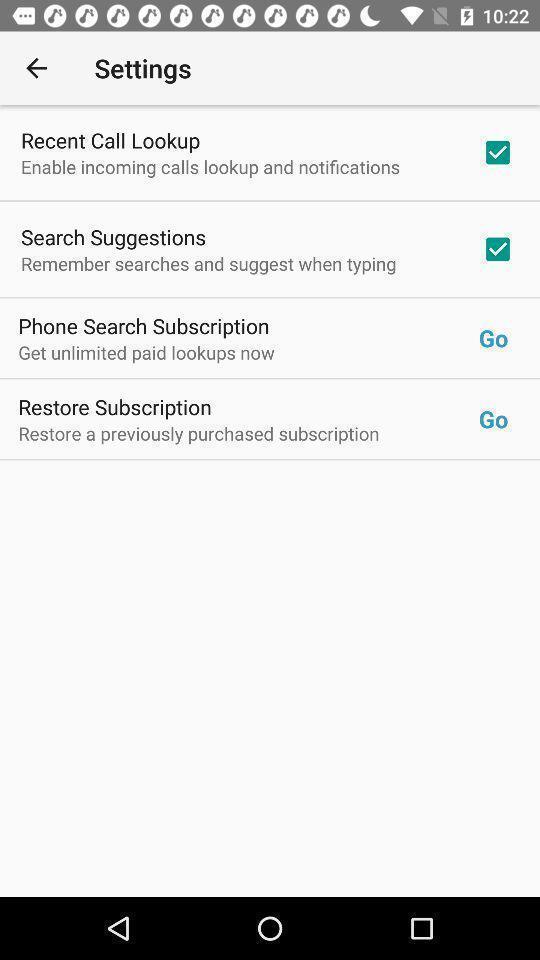Describe this image in words. Screen showing settings page. 